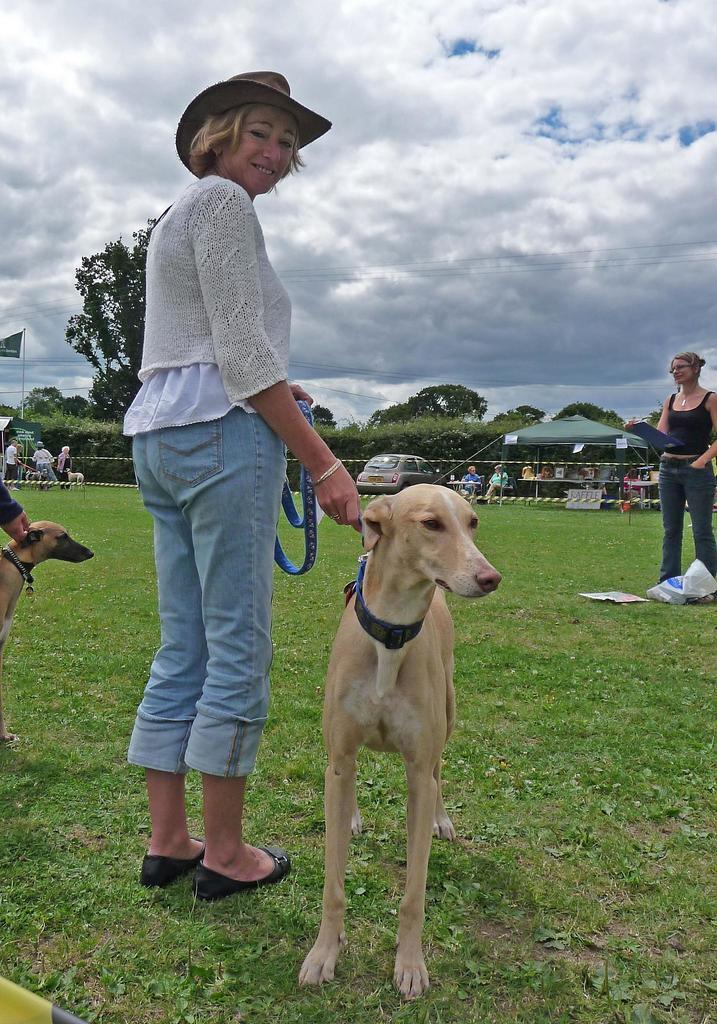Describe this image in one or two sentences. In this picture there is a woman standing on a greenery ground and holding a belt which is tightened to a dog beside her and there are another dog in the left corner and there is a woman standing in the right corner and there are few trees and some other persons in the background and the sky is cloudy. 